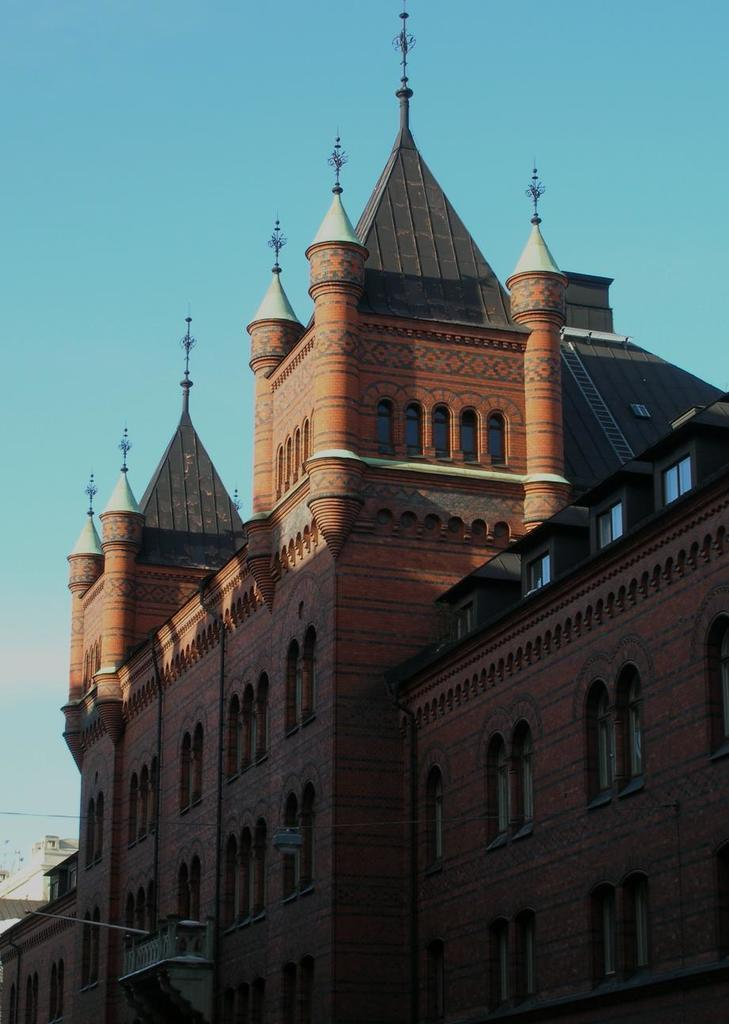What type of structure is depicted in the image? There is a building in the image that resembles a palace. What can be seen in the background of the image? The sky is visible at the top of the image. Can you see any boys wearing veils in the image? There are no boys or veils present in the image. Is there a letter addressed to the palace in the image? There is no letter visible in the image. 